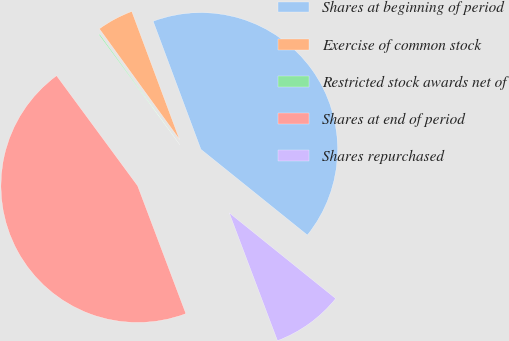Convert chart. <chart><loc_0><loc_0><loc_500><loc_500><pie_chart><fcel>Shares at beginning of period<fcel>Exercise of common stock<fcel>Restricted stock awards net of<fcel>Shares at end of period<fcel>Shares repurchased<nl><fcel>41.47%<fcel>4.3%<fcel>0.12%<fcel>45.65%<fcel>8.47%<nl></chart> 